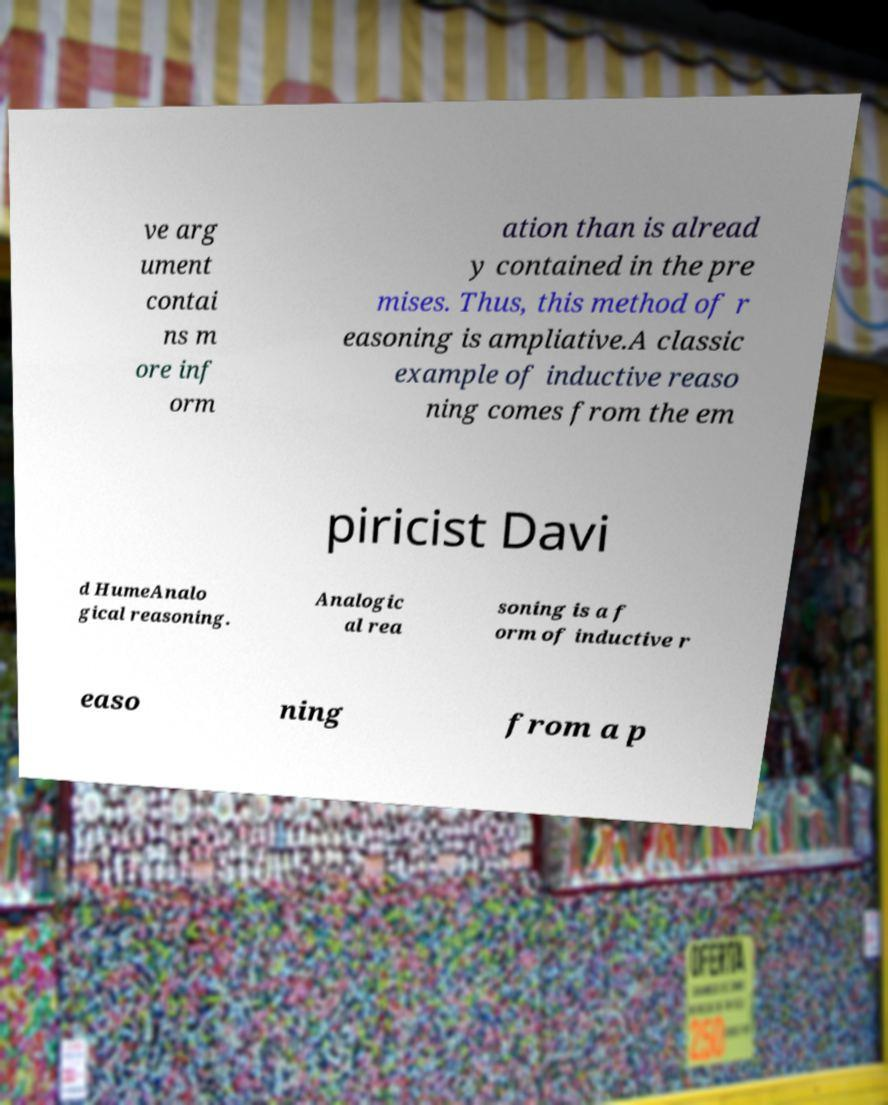I need the written content from this picture converted into text. Can you do that? ve arg ument contai ns m ore inf orm ation than is alread y contained in the pre mises. Thus, this method of r easoning is ampliative.A classic example of inductive reaso ning comes from the em piricist Davi d HumeAnalo gical reasoning. Analogic al rea soning is a f orm of inductive r easo ning from a p 